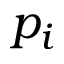Convert formula to latex. <formula><loc_0><loc_0><loc_500><loc_500>p _ { i }</formula> 